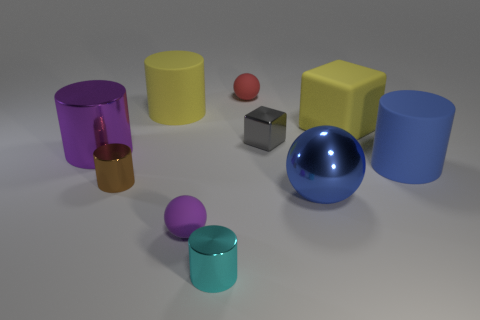Subtract all purple cylinders. How many cylinders are left? 4 Subtract all purple cylinders. How many cylinders are left? 4 Subtract all red cylinders. Subtract all cyan spheres. How many cylinders are left? 5 Subtract all spheres. How many objects are left? 7 Add 7 small matte things. How many small matte things are left? 9 Add 3 balls. How many balls exist? 6 Subtract 1 yellow cylinders. How many objects are left? 9 Subtract all tiny brown metallic cylinders. Subtract all yellow cylinders. How many objects are left? 8 